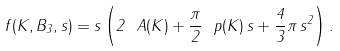<formula> <loc_0><loc_0><loc_500><loc_500>f ( K , B _ { 3 } , s ) = s \left ( 2 \ A ( K ) + \frac { \pi } { 2 } \ p ( K ) \, s + \frac { 4 } { 3 } \pi \, s ^ { 2 } \right ) .</formula> 